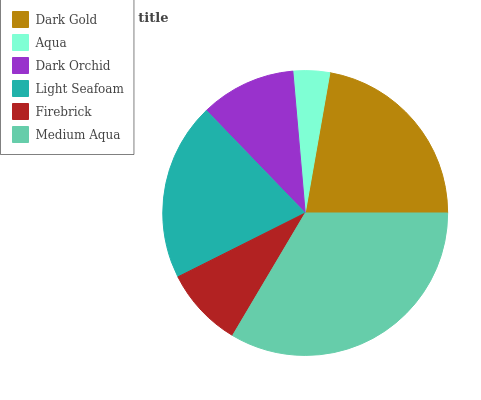Is Aqua the minimum?
Answer yes or no. Yes. Is Medium Aqua the maximum?
Answer yes or no. Yes. Is Dark Orchid the minimum?
Answer yes or no. No. Is Dark Orchid the maximum?
Answer yes or no. No. Is Dark Orchid greater than Aqua?
Answer yes or no. Yes. Is Aqua less than Dark Orchid?
Answer yes or no. Yes. Is Aqua greater than Dark Orchid?
Answer yes or no. No. Is Dark Orchid less than Aqua?
Answer yes or no. No. Is Light Seafoam the high median?
Answer yes or no. Yes. Is Dark Orchid the low median?
Answer yes or no. Yes. Is Medium Aqua the high median?
Answer yes or no. No. Is Medium Aqua the low median?
Answer yes or no. No. 